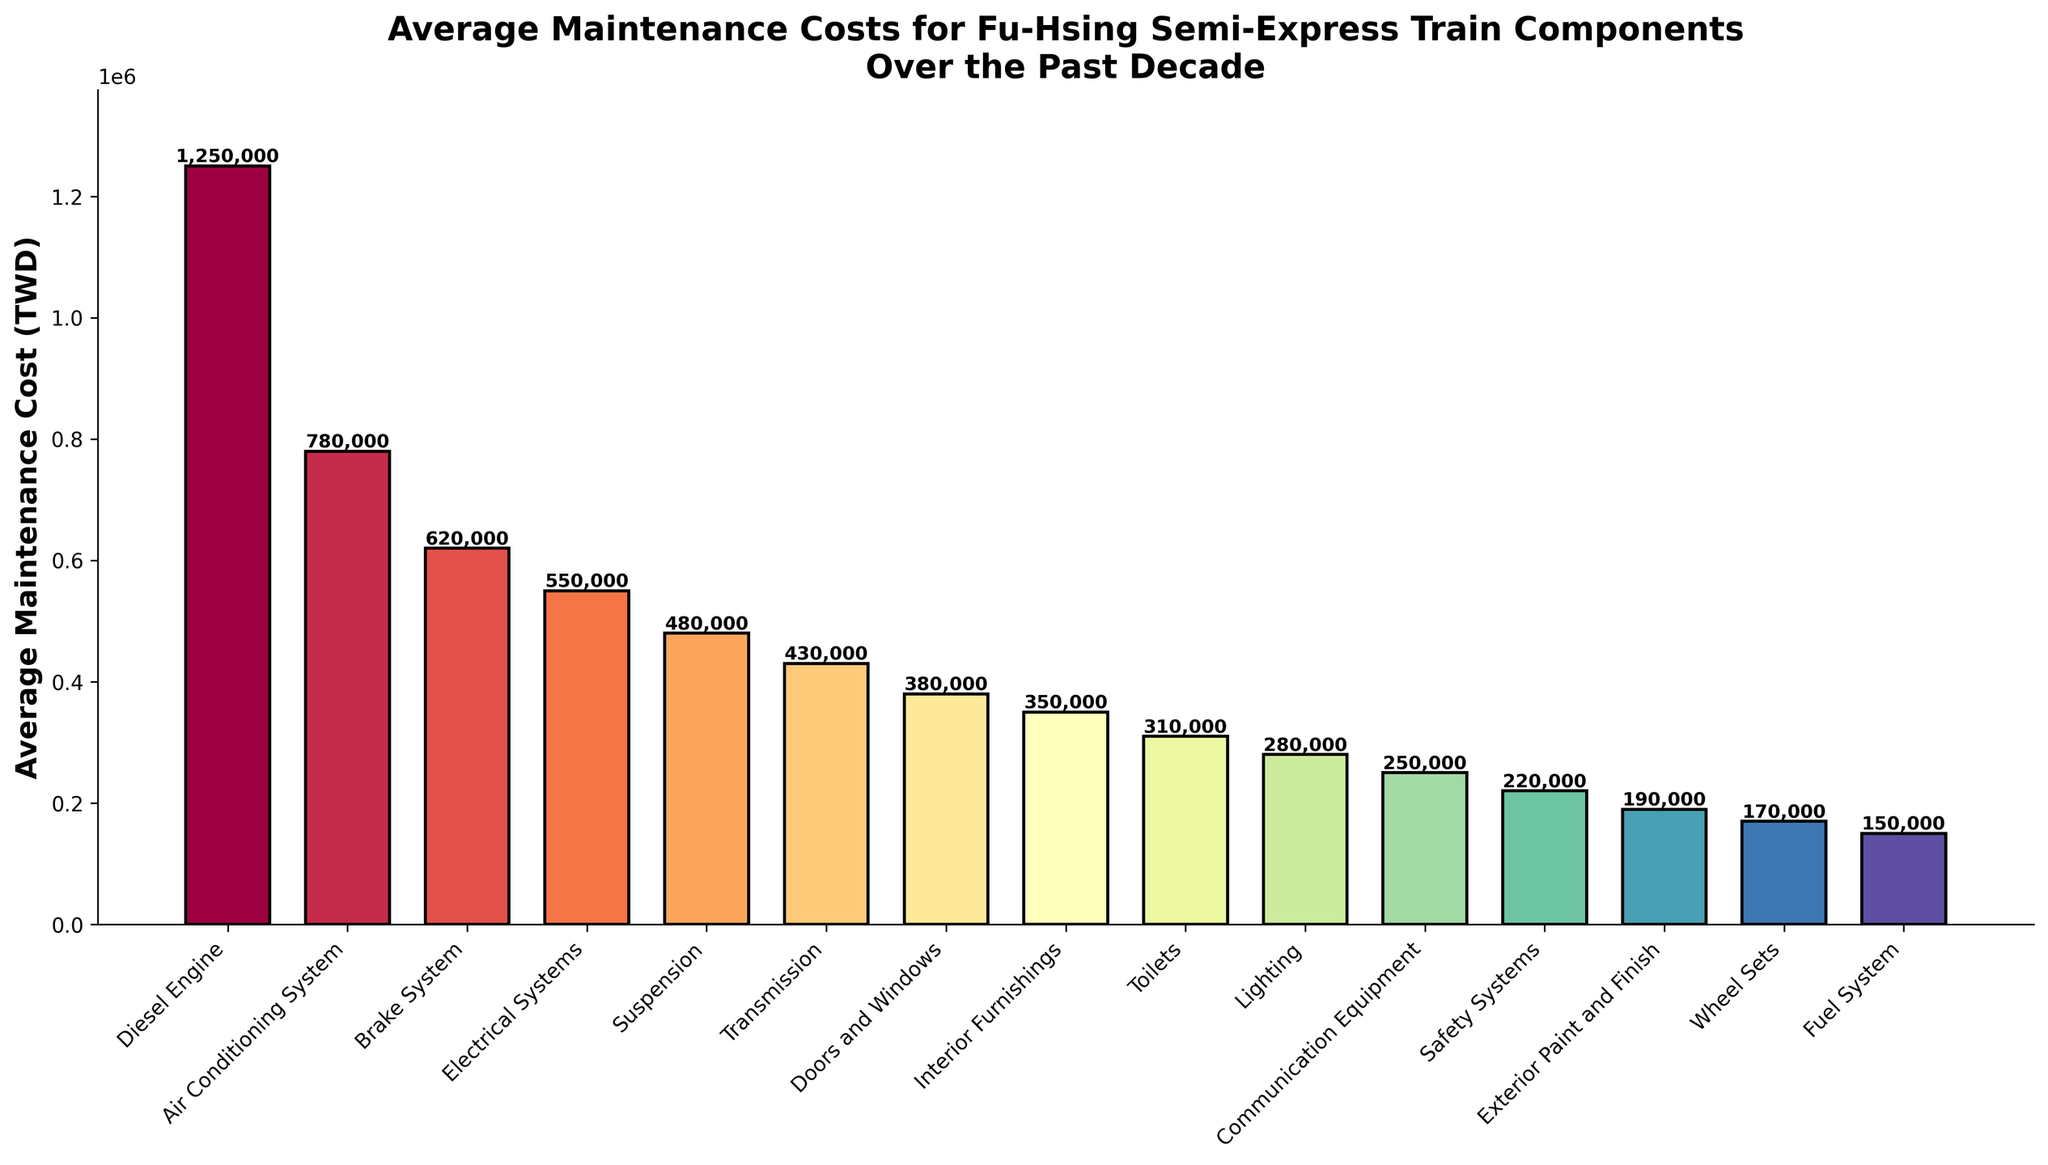What's the average maintenance cost for the Diesel Engine and the Air Conditioning System combined? To find the average maintenance cost, add the costs of the Diesel Engine (1,250,000 TWD) and the Air Conditioning System (780,000 TWD), then divide by 2. \( \frac{1,250,000 + 780,000}{2} = 1,015,000 \) TWD.
Answer: 1,015,000 TWD Which component has the lowest average maintenance cost? The components should be compared based on their average maintenance costs. The Fuel System has the lowest cost of 150,000 TWD.
Answer: Fuel System Is the average maintenance cost of the Brake System higher than that of the Electrical Systems? Compare the average maintenance costs: the Brake System costs 620,000 TWD, while the Electrical Systems cost 550,000 TWD. 620,000 is greater than 550,000.
Answer: Yes What is the total average maintenance cost for the Doors and Windows, Interior Furnishings, and Toilets combined? Sum the average maintenance costs: Doors and Windows (380,000 TWD), Interior Furnishings (350,000 TWD), and Toilets (310,000 TWD). \( 380,000 + 350,000 + 310,000 = 1,040,000 \) TWD.
Answer: 1,040,000 TWD How does the average maintenance cost of the Lighting compare to that of the Communication Equipment? Compare the two costs: Lighting costs 280,000 TWD, while Communication Equipment costs 250,000 TWD. 280,000 TWD is greater than 250,000 TWD.
Answer: Lighting is higher Which component has the highest average maintenance cost and how much is it? From the bar chart, identify the component with the tallest bar and read the value. The Diesel Engine has the highest cost, which is 1,250,000 TWD.
Answer: Diesel Engine, 1,250,000 TWD What is the difference in average maintenance costs between the Transmission and the Suspension? Calculate the difference by subtracting the Transmission cost (430,000 TWD) from the Suspension cost (480,000 TWD). \( 480,000 - 430,000 = 50,000 \) TWD.
Answer: 50,000 TWD Which component costs more to maintain: the Exterior Paint and Finish or the Wheel Sets? Compare the average maintenance costs: Exterior Paint and Finish costs 190,000 TWD, while the Wheel Sets cost 170,000 TWD. 190,000 TWD is greater than 170,000 TWD.
Answer: Exterior Paint and Finish Do the combined average maintenance costs for the Safety Systems and the Fuel System exceed that of the Transmission? Sum the average maintenance costs of Safety Systems (220,000 TWD) and Fuel System (150,000 TWD) and compare to Transmission (430,000 TWD). \( 220,000 + 150,000 = 370,000 \) TWD, which is less than 430,000 TWD.
Answer: No What is the combined maintenance cost for the top three most costly components? Identify and sum the top three costs: Diesel Engine (1,250,000 TWD), Air Conditioning System (780,000 TWD), and Brake System (620,000 TWD). \( 1,250,000 + 780,000 + 620,000 = 2,650,000 \) TWD.
Answer: 2,650,000 TWD 